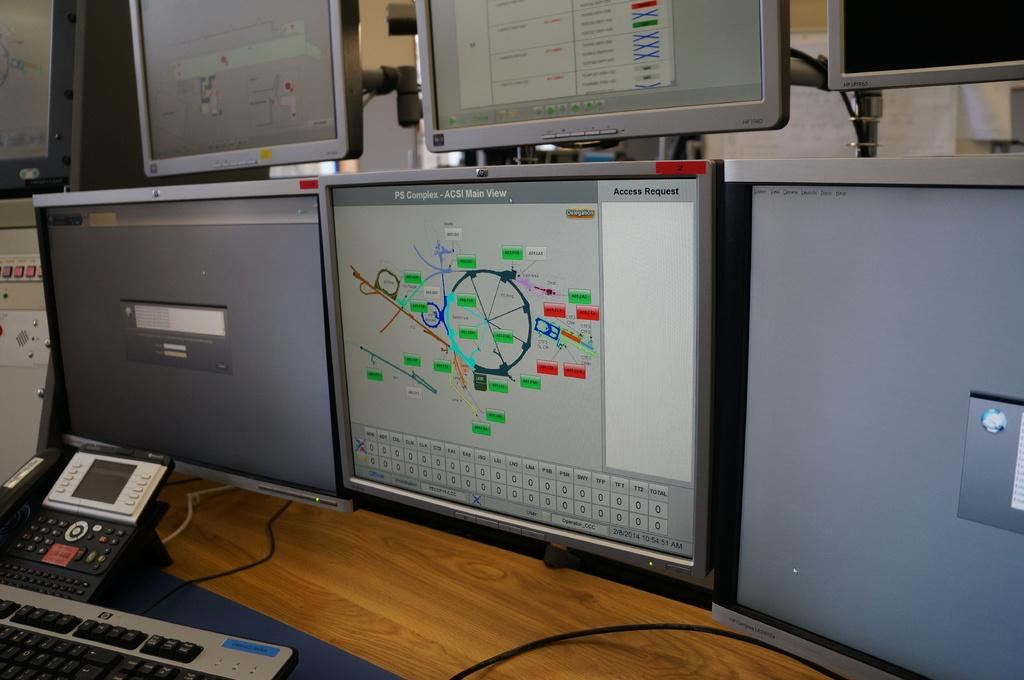Provide a one-sentence caption for the provided image. The middle computer screen has an access request on the top right. 